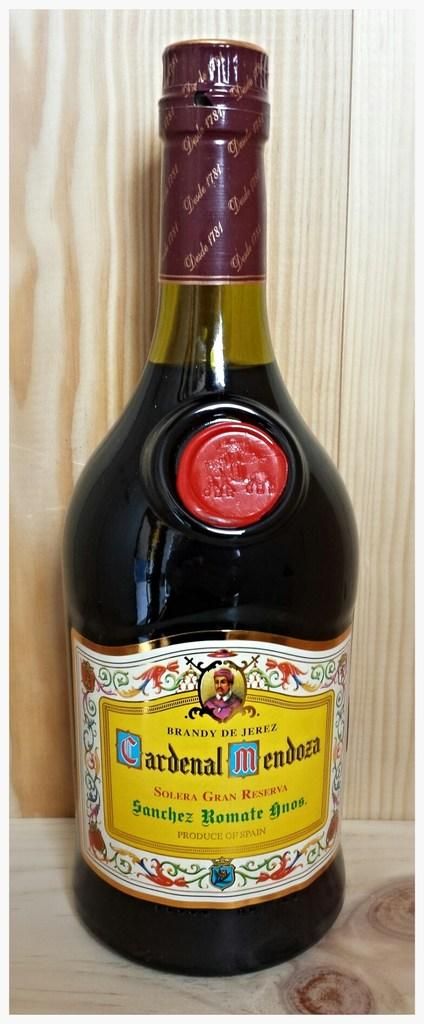<image>
Relay a brief, clear account of the picture shown. A bottle of Crdenal Mendoza Brandy sitting on a wood shelf. 